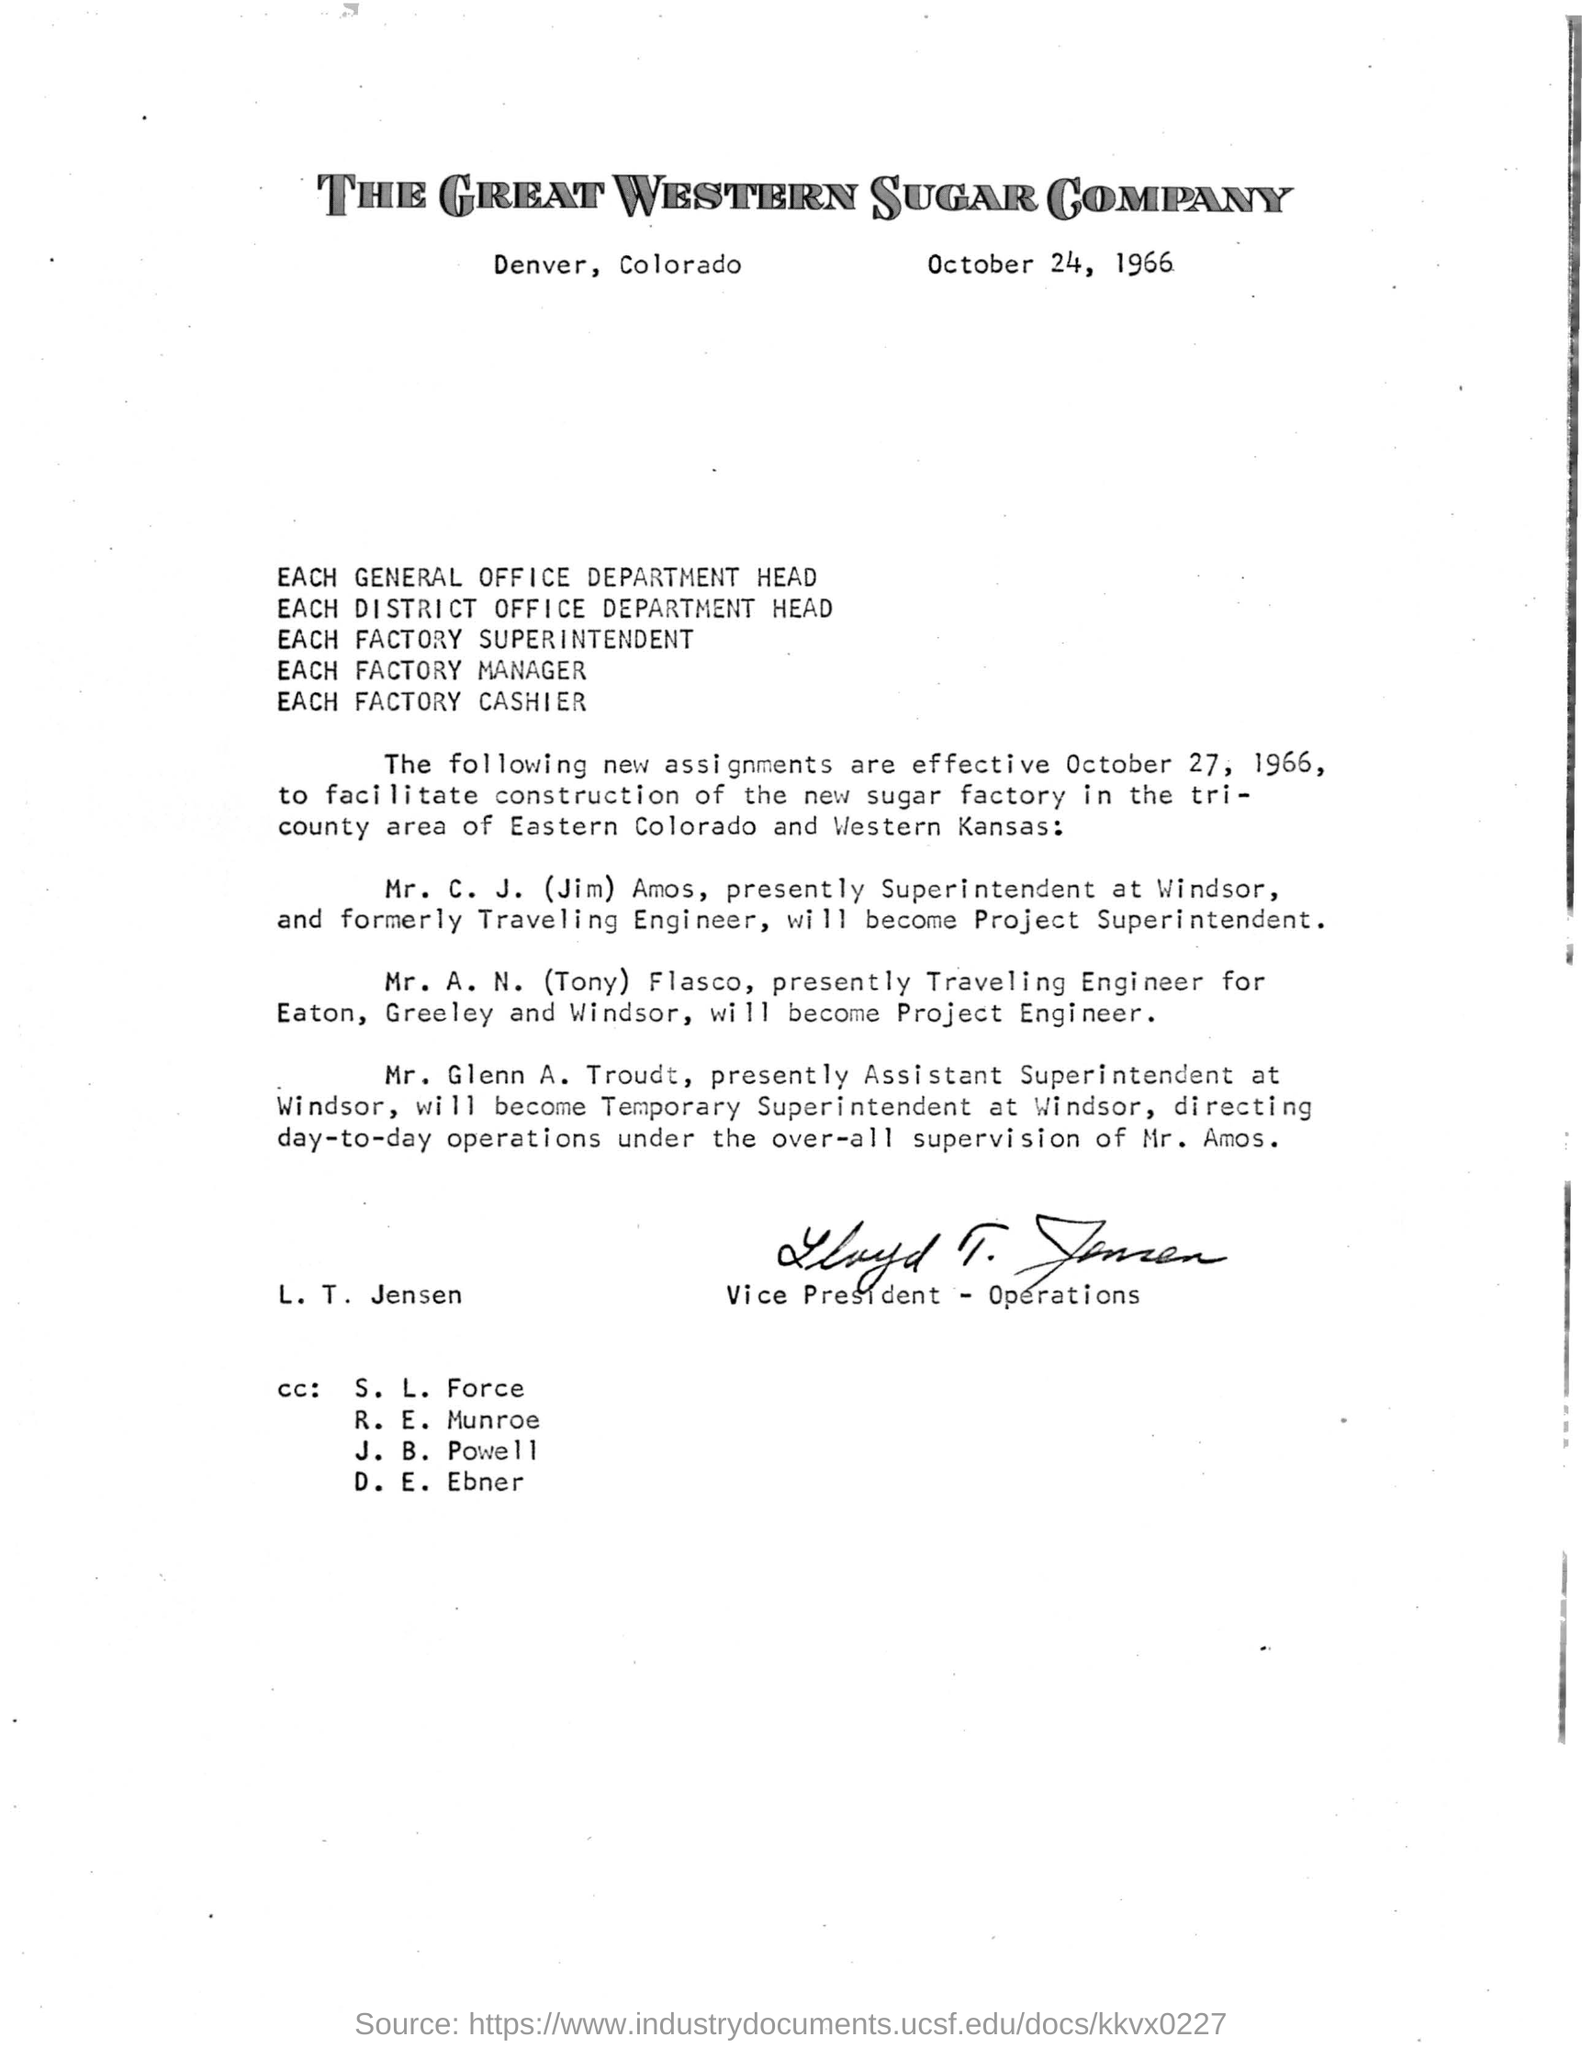Highlight a few significant elements in this photo. The issued date of the letter is October 24, 1966. The signature on the letter is that of L. T. Jensen. 